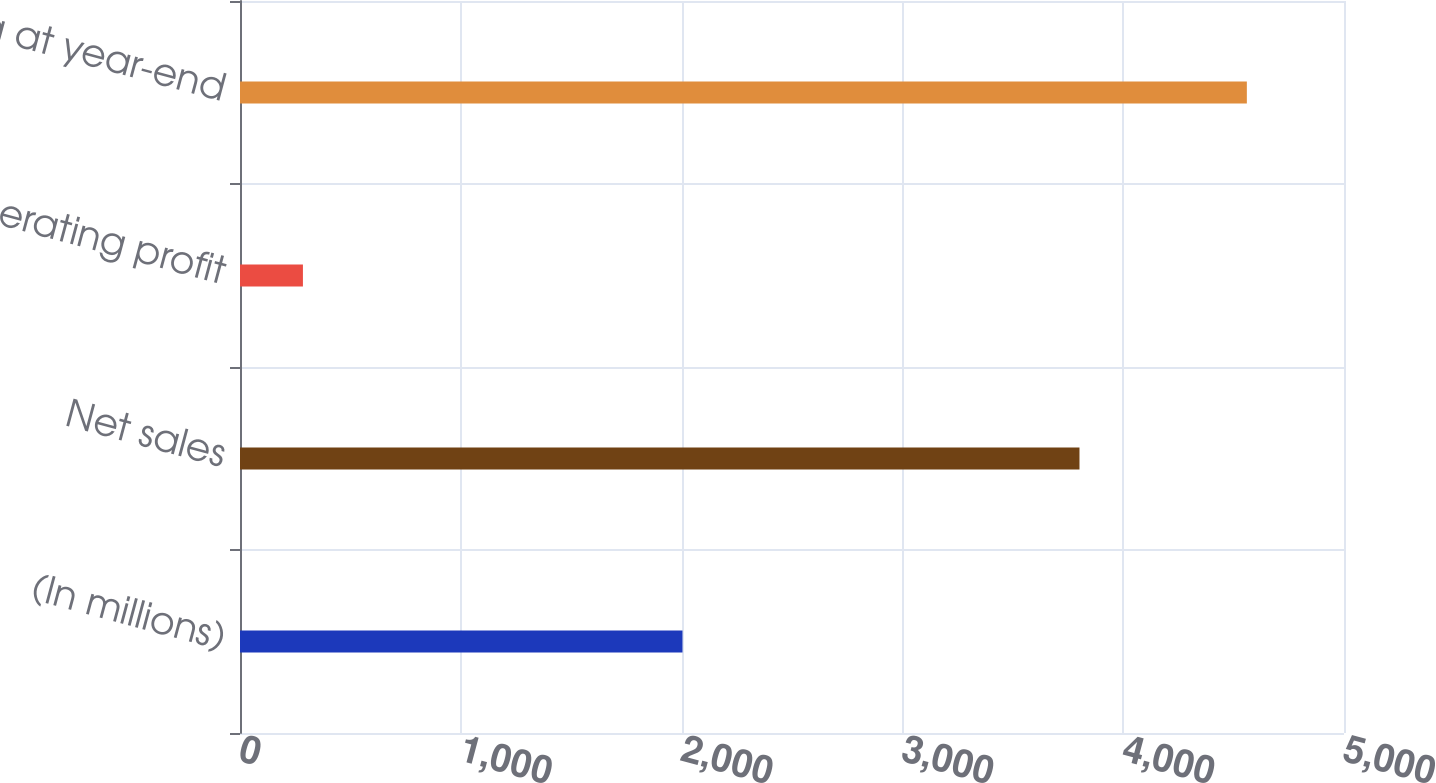<chart> <loc_0><loc_0><loc_500><loc_500><bar_chart><fcel>(In millions)<fcel>Net sales<fcel>Operating profit<fcel>Backlog at year-end<nl><fcel>2004<fcel>3802<fcel>285<fcel>4560<nl></chart> 